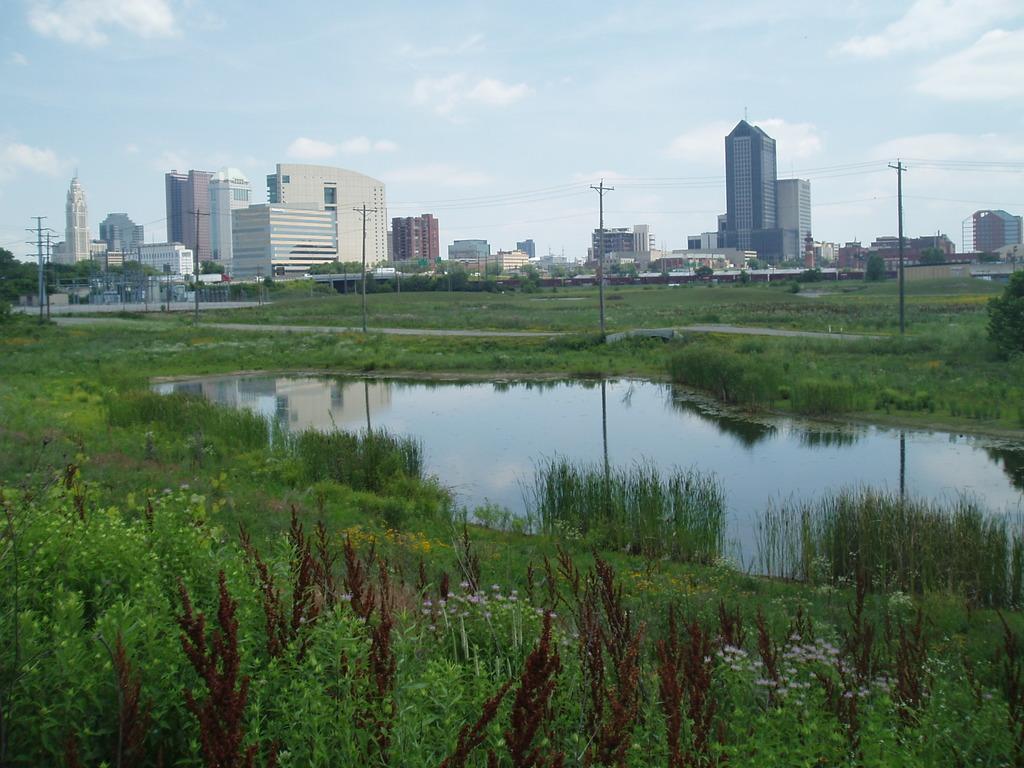Can you describe this image briefly? This is an outside view. At the bottom there are many plants along with the flowers. In the middle of the image there is a pond. In the background there are many trees, buildings and poles. At the top of the image I can see the sky and clouds. 